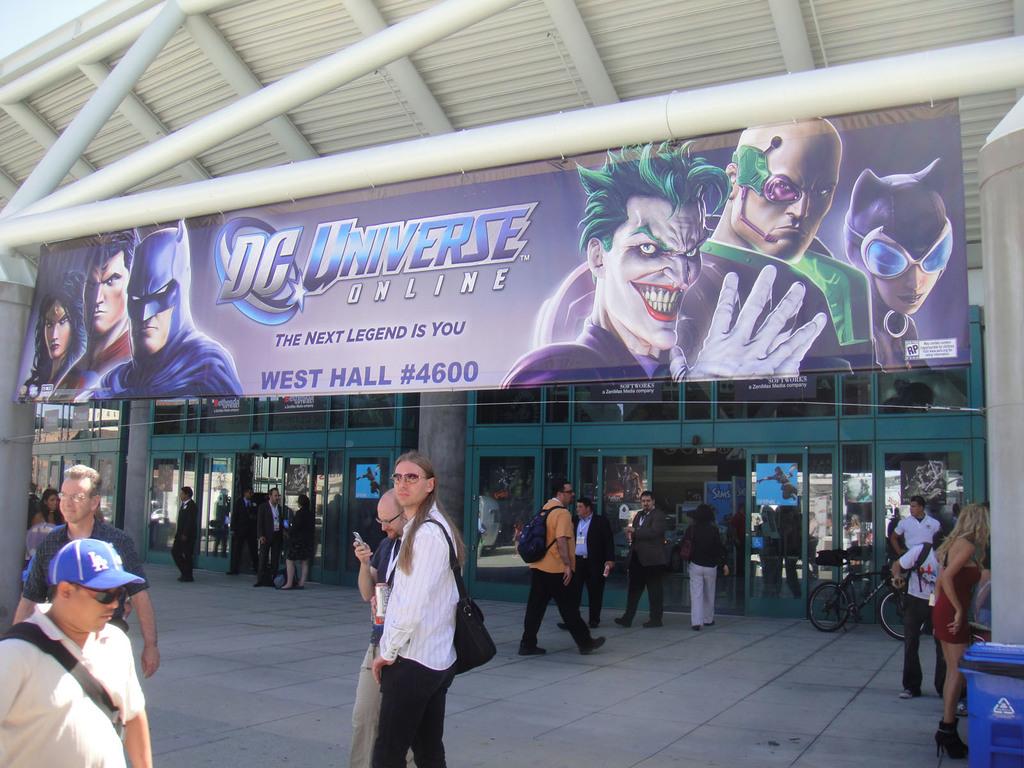Who is the next legend, according to the sign?
Your answer should be compact. You. 